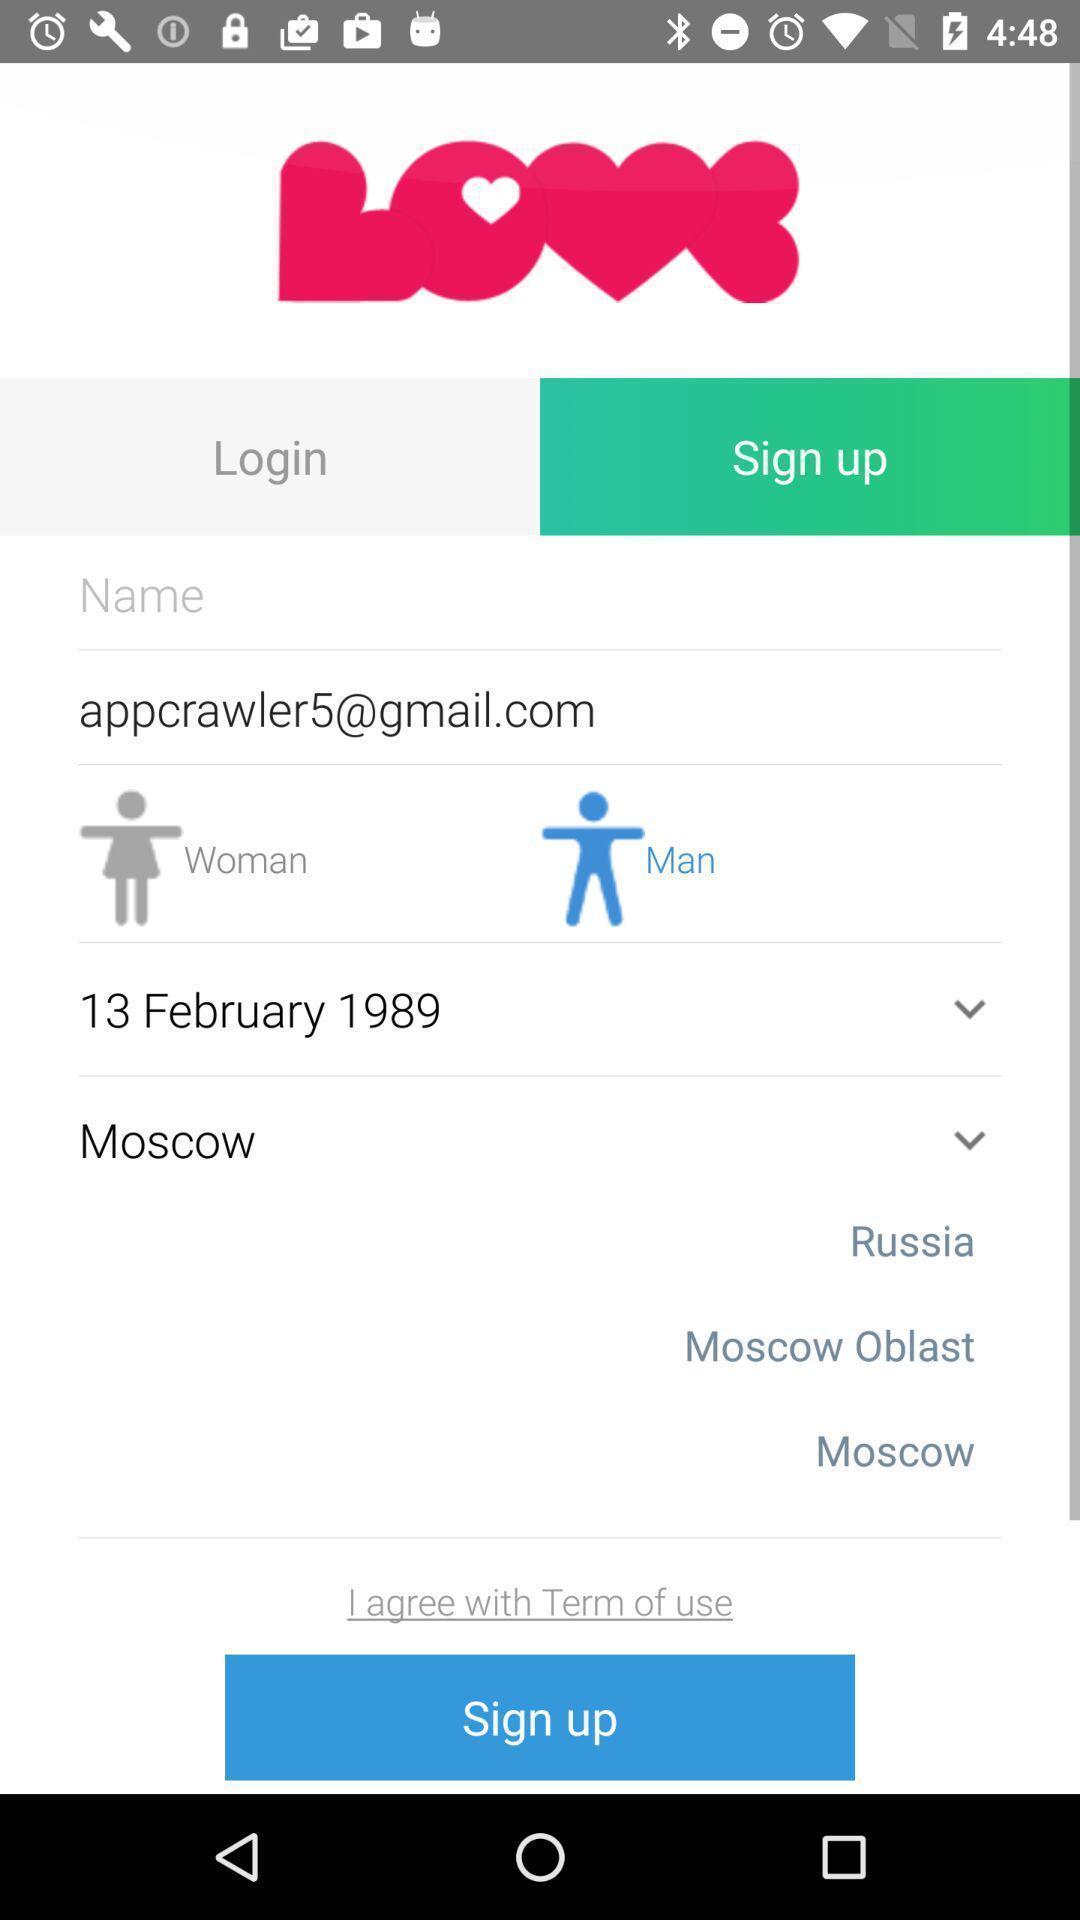Summarize the information in this screenshot. Sign up page. 